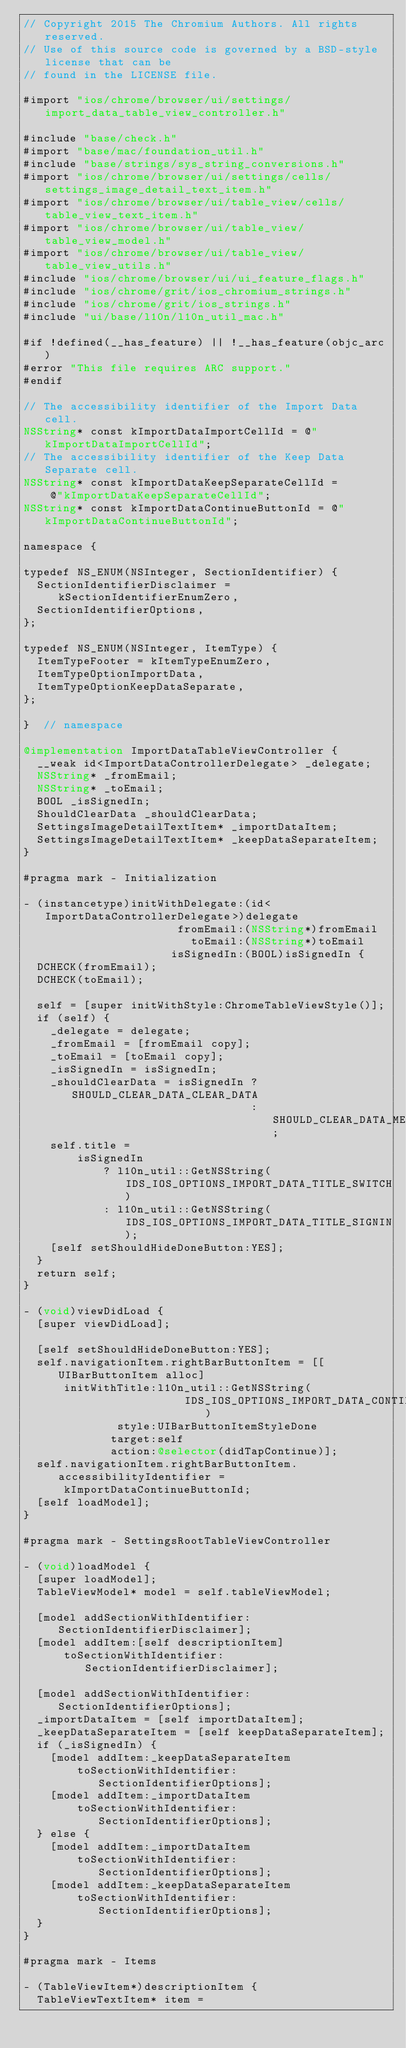Convert code to text. <code><loc_0><loc_0><loc_500><loc_500><_ObjectiveC_>// Copyright 2015 The Chromium Authors. All rights reserved.
// Use of this source code is governed by a BSD-style license that can be
// found in the LICENSE file.

#import "ios/chrome/browser/ui/settings/import_data_table_view_controller.h"

#include "base/check.h"
#import "base/mac/foundation_util.h"
#include "base/strings/sys_string_conversions.h"
#import "ios/chrome/browser/ui/settings/cells/settings_image_detail_text_item.h"
#import "ios/chrome/browser/ui/table_view/cells/table_view_text_item.h"
#import "ios/chrome/browser/ui/table_view/table_view_model.h"
#import "ios/chrome/browser/ui/table_view/table_view_utils.h"
#include "ios/chrome/browser/ui/ui_feature_flags.h"
#include "ios/chrome/grit/ios_chromium_strings.h"
#include "ios/chrome/grit/ios_strings.h"
#include "ui/base/l10n/l10n_util_mac.h"

#if !defined(__has_feature) || !__has_feature(objc_arc)
#error "This file requires ARC support."
#endif

// The accessibility identifier of the Import Data cell.
NSString* const kImportDataImportCellId = @"kImportDataImportCellId";
// The accessibility identifier of the Keep Data Separate cell.
NSString* const kImportDataKeepSeparateCellId =
    @"kImportDataKeepSeparateCellId";
NSString* const kImportDataContinueButtonId = @"kImportDataContinueButtonId";

namespace {

typedef NS_ENUM(NSInteger, SectionIdentifier) {
  SectionIdentifierDisclaimer = kSectionIdentifierEnumZero,
  SectionIdentifierOptions,
};

typedef NS_ENUM(NSInteger, ItemType) {
  ItemTypeFooter = kItemTypeEnumZero,
  ItemTypeOptionImportData,
  ItemTypeOptionKeepDataSeparate,
};

}  // namespace

@implementation ImportDataTableViewController {
  __weak id<ImportDataControllerDelegate> _delegate;
  NSString* _fromEmail;
  NSString* _toEmail;
  BOOL _isSignedIn;
  ShouldClearData _shouldClearData;
  SettingsImageDetailTextItem* _importDataItem;
  SettingsImageDetailTextItem* _keepDataSeparateItem;
}

#pragma mark - Initialization

- (instancetype)initWithDelegate:(id<ImportDataControllerDelegate>)delegate
                       fromEmail:(NSString*)fromEmail
                         toEmail:(NSString*)toEmail
                      isSignedIn:(BOOL)isSignedIn {
  DCHECK(fromEmail);
  DCHECK(toEmail);

  self = [super initWithStyle:ChromeTableViewStyle()];
  if (self) {
    _delegate = delegate;
    _fromEmail = [fromEmail copy];
    _toEmail = [toEmail copy];
    _isSignedIn = isSignedIn;
    _shouldClearData = isSignedIn ? SHOULD_CLEAR_DATA_CLEAR_DATA
                                  : SHOULD_CLEAR_DATA_MERGE_DATA;
    self.title =
        isSignedIn
            ? l10n_util::GetNSString(IDS_IOS_OPTIONS_IMPORT_DATA_TITLE_SWITCH)
            : l10n_util::GetNSString(IDS_IOS_OPTIONS_IMPORT_DATA_TITLE_SIGNIN);
    [self setShouldHideDoneButton:YES];
  }
  return self;
}

- (void)viewDidLoad {
  [super viewDidLoad];

  [self setShouldHideDoneButton:YES];
  self.navigationItem.rightBarButtonItem = [[UIBarButtonItem alloc]
      initWithTitle:l10n_util::GetNSString(
                        IDS_IOS_OPTIONS_IMPORT_DATA_CONTINUE_BUTTON)
              style:UIBarButtonItemStyleDone
             target:self
             action:@selector(didTapContinue)];
  self.navigationItem.rightBarButtonItem.accessibilityIdentifier =
      kImportDataContinueButtonId;
  [self loadModel];
}

#pragma mark - SettingsRootTableViewController

- (void)loadModel {
  [super loadModel];
  TableViewModel* model = self.tableViewModel;

  [model addSectionWithIdentifier:SectionIdentifierDisclaimer];
  [model addItem:[self descriptionItem]
      toSectionWithIdentifier:SectionIdentifierDisclaimer];

  [model addSectionWithIdentifier:SectionIdentifierOptions];
  _importDataItem = [self importDataItem];
  _keepDataSeparateItem = [self keepDataSeparateItem];
  if (_isSignedIn) {
    [model addItem:_keepDataSeparateItem
        toSectionWithIdentifier:SectionIdentifierOptions];
    [model addItem:_importDataItem
        toSectionWithIdentifier:SectionIdentifierOptions];
  } else {
    [model addItem:_importDataItem
        toSectionWithIdentifier:SectionIdentifierOptions];
    [model addItem:_keepDataSeparateItem
        toSectionWithIdentifier:SectionIdentifierOptions];
  }
}

#pragma mark - Items

- (TableViewItem*)descriptionItem {
  TableViewTextItem* item =</code> 